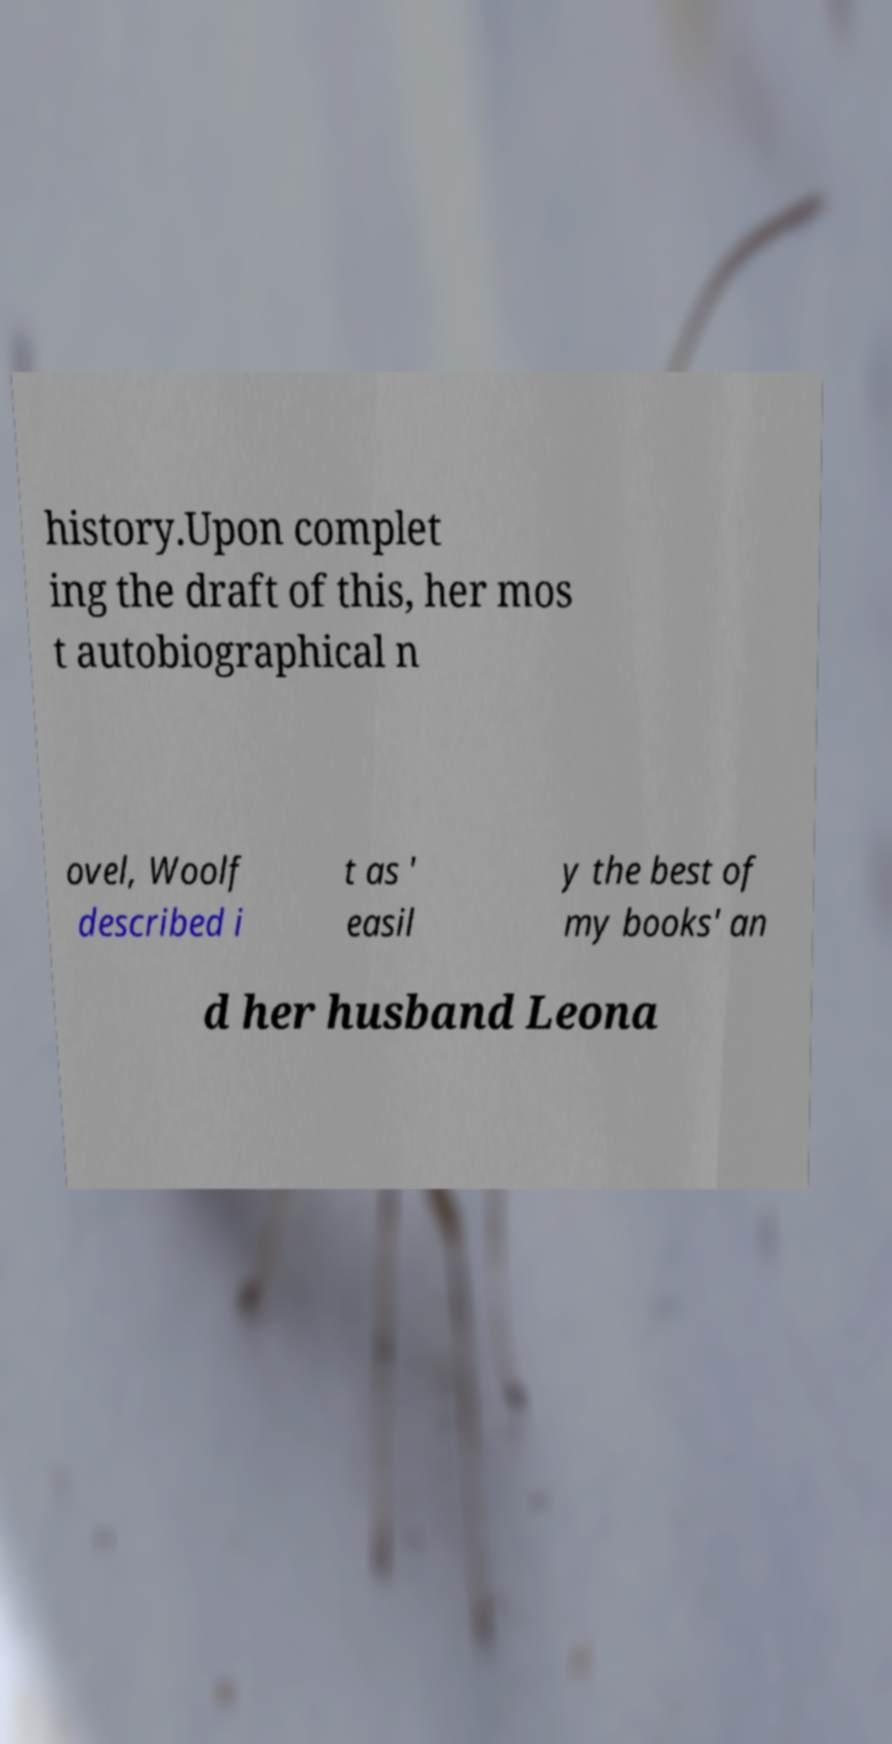There's text embedded in this image that I need extracted. Can you transcribe it verbatim? history.Upon complet ing the draft of this, her mos t autobiographical n ovel, Woolf described i t as ' easil y the best of my books' an d her husband Leona 